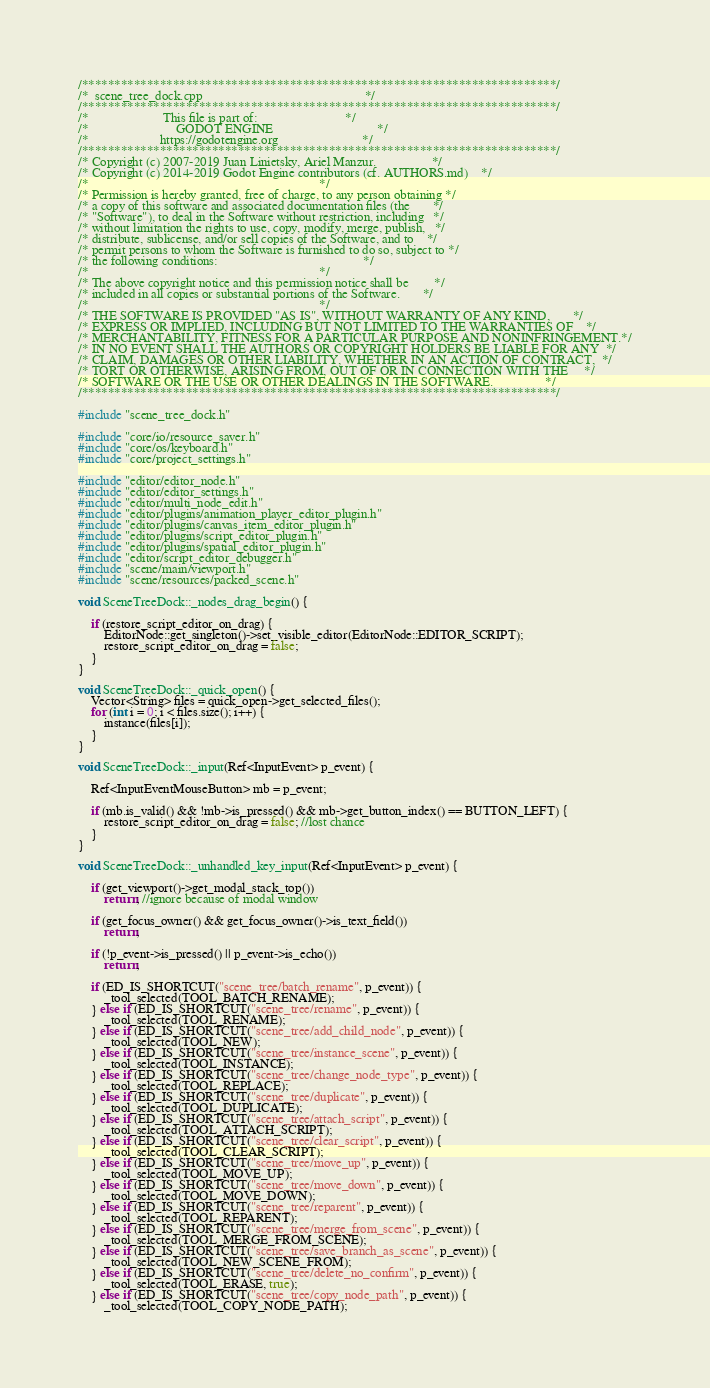Convert code to text. <code><loc_0><loc_0><loc_500><loc_500><_C++_>/*************************************************************************/
/*  scene_tree_dock.cpp                                                  */
/*************************************************************************/
/*                       This file is part of:                           */
/*                           GODOT ENGINE                                */
/*                      https://godotengine.org                          */
/*************************************************************************/
/* Copyright (c) 2007-2019 Juan Linietsky, Ariel Manzur.                 */
/* Copyright (c) 2014-2019 Godot Engine contributors (cf. AUTHORS.md)    */
/*                                                                       */
/* Permission is hereby granted, free of charge, to any person obtaining */
/* a copy of this software and associated documentation files (the       */
/* "Software"), to deal in the Software without restriction, including   */
/* without limitation the rights to use, copy, modify, merge, publish,   */
/* distribute, sublicense, and/or sell copies of the Software, and to    */
/* permit persons to whom the Software is furnished to do so, subject to */
/* the following conditions:                                             */
/*                                                                       */
/* The above copyright notice and this permission notice shall be        */
/* included in all copies or substantial portions of the Software.       */
/*                                                                       */
/* THE SOFTWARE IS PROVIDED "AS IS", WITHOUT WARRANTY OF ANY KIND,       */
/* EXPRESS OR IMPLIED, INCLUDING BUT NOT LIMITED TO THE WARRANTIES OF    */
/* MERCHANTABILITY, FITNESS FOR A PARTICULAR PURPOSE AND NONINFRINGEMENT.*/
/* IN NO EVENT SHALL THE AUTHORS OR COPYRIGHT HOLDERS BE LIABLE FOR ANY  */
/* CLAIM, DAMAGES OR OTHER LIABILITY, WHETHER IN AN ACTION OF CONTRACT,  */
/* TORT OR OTHERWISE, ARISING FROM, OUT OF OR IN CONNECTION WITH THE     */
/* SOFTWARE OR THE USE OR OTHER DEALINGS IN THE SOFTWARE.                */
/*************************************************************************/

#include "scene_tree_dock.h"

#include "core/io/resource_saver.h"
#include "core/os/keyboard.h"
#include "core/project_settings.h"

#include "editor/editor_node.h"
#include "editor/editor_settings.h"
#include "editor/multi_node_edit.h"
#include "editor/plugins/animation_player_editor_plugin.h"
#include "editor/plugins/canvas_item_editor_plugin.h"
#include "editor/plugins/script_editor_plugin.h"
#include "editor/plugins/spatial_editor_plugin.h"
#include "editor/script_editor_debugger.h"
#include "scene/main/viewport.h"
#include "scene/resources/packed_scene.h"

void SceneTreeDock::_nodes_drag_begin() {

	if (restore_script_editor_on_drag) {
		EditorNode::get_singleton()->set_visible_editor(EditorNode::EDITOR_SCRIPT);
		restore_script_editor_on_drag = false;
	}
}

void SceneTreeDock::_quick_open() {
	Vector<String> files = quick_open->get_selected_files();
	for (int i = 0; i < files.size(); i++) {
		instance(files[i]);
	}
}

void SceneTreeDock::_input(Ref<InputEvent> p_event) {

	Ref<InputEventMouseButton> mb = p_event;

	if (mb.is_valid() && !mb->is_pressed() && mb->get_button_index() == BUTTON_LEFT) {
		restore_script_editor_on_drag = false; //lost chance
	}
}

void SceneTreeDock::_unhandled_key_input(Ref<InputEvent> p_event) {

	if (get_viewport()->get_modal_stack_top())
		return; //ignore because of modal window

	if (get_focus_owner() && get_focus_owner()->is_text_field())
		return;

	if (!p_event->is_pressed() || p_event->is_echo())
		return;

	if (ED_IS_SHORTCUT("scene_tree/batch_rename", p_event)) {
		_tool_selected(TOOL_BATCH_RENAME);
	} else if (ED_IS_SHORTCUT("scene_tree/rename", p_event)) {
		_tool_selected(TOOL_RENAME);
	} else if (ED_IS_SHORTCUT("scene_tree/add_child_node", p_event)) {
		_tool_selected(TOOL_NEW);
	} else if (ED_IS_SHORTCUT("scene_tree/instance_scene", p_event)) {
		_tool_selected(TOOL_INSTANCE);
	} else if (ED_IS_SHORTCUT("scene_tree/change_node_type", p_event)) {
		_tool_selected(TOOL_REPLACE);
	} else if (ED_IS_SHORTCUT("scene_tree/duplicate", p_event)) {
		_tool_selected(TOOL_DUPLICATE);
	} else if (ED_IS_SHORTCUT("scene_tree/attach_script", p_event)) {
		_tool_selected(TOOL_ATTACH_SCRIPT);
	} else if (ED_IS_SHORTCUT("scene_tree/clear_script", p_event)) {
		_tool_selected(TOOL_CLEAR_SCRIPT);
	} else if (ED_IS_SHORTCUT("scene_tree/move_up", p_event)) {
		_tool_selected(TOOL_MOVE_UP);
	} else if (ED_IS_SHORTCUT("scene_tree/move_down", p_event)) {
		_tool_selected(TOOL_MOVE_DOWN);
	} else if (ED_IS_SHORTCUT("scene_tree/reparent", p_event)) {
		_tool_selected(TOOL_REPARENT);
	} else if (ED_IS_SHORTCUT("scene_tree/merge_from_scene", p_event)) {
		_tool_selected(TOOL_MERGE_FROM_SCENE);
	} else if (ED_IS_SHORTCUT("scene_tree/save_branch_as_scene", p_event)) {
		_tool_selected(TOOL_NEW_SCENE_FROM);
	} else if (ED_IS_SHORTCUT("scene_tree/delete_no_confirm", p_event)) {
		_tool_selected(TOOL_ERASE, true);
	} else if (ED_IS_SHORTCUT("scene_tree/copy_node_path", p_event)) {
		_tool_selected(TOOL_COPY_NODE_PATH);</code> 